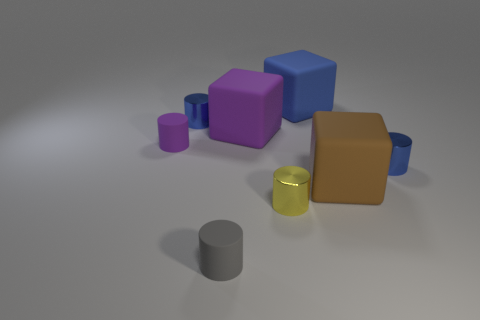The metal thing that is in front of the big brown matte object is what color?
Provide a succinct answer. Yellow. Is there a big object that is in front of the small blue metallic object in front of the purple matte object to the left of the gray matte thing?
Offer a very short reply. Yes. Is the number of blue metallic things that are on the left side of the purple matte cylinder greater than the number of small yellow metal things?
Your answer should be very brief. No. There is a shiny thing on the right side of the large brown thing; is it the same shape as the brown object?
Provide a succinct answer. No. Is there any other thing that is the same material as the large brown cube?
Provide a succinct answer. Yes. What number of things are either purple things or small things that are right of the purple matte cylinder?
Give a very brief answer. 6. How big is the rubber object that is both left of the purple block and behind the big brown block?
Your response must be concise. Small. Are there more big brown matte cubes behind the blue cube than small blue cylinders that are left of the big brown cube?
Keep it short and to the point. No. There is a big purple object; is it the same shape as the blue thing that is in front of the small purple rubber thing?
Offer a very short reply. No. How many other things are there of the same shape as the yellow shiny object?
Offer a terse response. 4. 